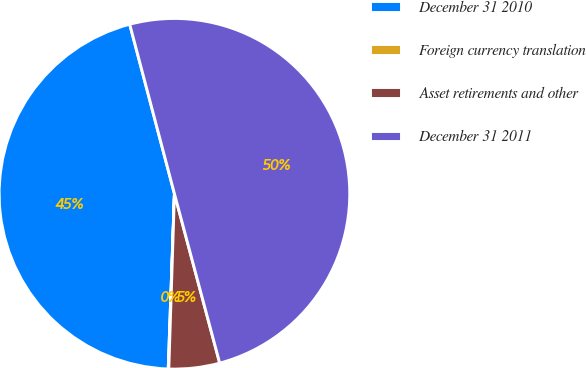Convert chart to OTSL. <chart><loc_0><loc_0><loc_500><loc_500><pie_chart><fcel>December 31 2010<fcel>Foreign currency translation<fcel>Asset retirements and other<fcel>December 31 2011<nl><fcel>45.33%<fcel>0.05%<fcel>4.67%<fcel>49.95%<nl></chart> 